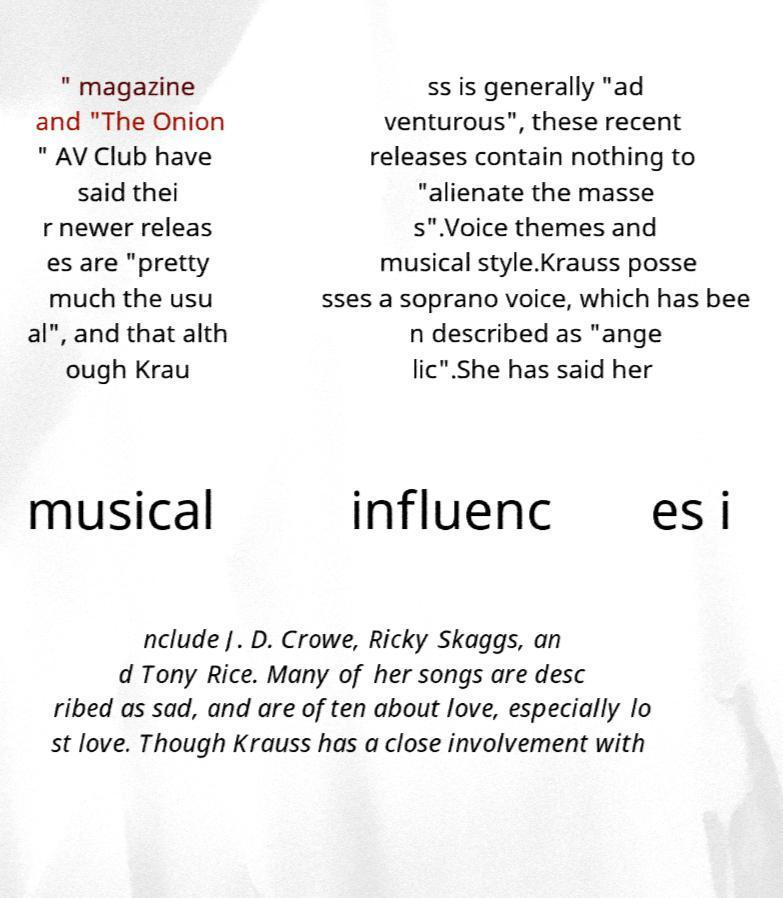Please read and relay the text visible in this image. What does it say? " magazine and "The Onion " AV Club have said thei r newer releas es are "pretty much the usu al", and that alth ough Krau ss is generally "ad venturous", these recent releases contain nothing to "alienate the masse s".Voice themes and musical style.Krauss posse sses a soprano voice, which has bee n described as "ange lic".She has said her musical influenc es i nclude J. D. Crowe, Ricky Skaggs, an d Tony Rice. Many of her songs are desc ribed as sad, and are often about love, especially lo st love. Though Krauss has a close involvement with 